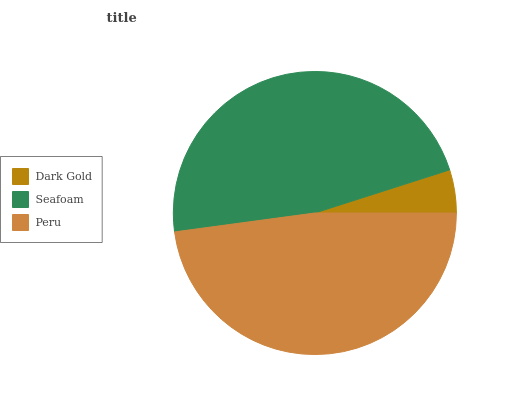Is Dark Gold the minimum?
Answer yes or no. Yes. Is Peru the maximum?
Answer yes or no. Yes. Is Seafoam the minimum?
Answer yes or no. No. Is Seafoam the maximum?
Answer yes or no. No. Is Seafoam greater than Dark Gold?
Answer yes or no. Yes. Is Dark Gold less than Seafoam?
Answer yes or no. Yes. Is Dark Gold greater than Seafoam?
Answer yes or no. No. Is Seafoam less than Dark Gold?
Answer yes or no. No. Is Seafoam the high median?
Answer yes or no. Yes. Is Seafoam the low median?
Answer yes or no. Yes. Is Dark Gold the high median?
Answer yes or no. No. Is Dark Gold the low median?
Answer yes or no. No. 